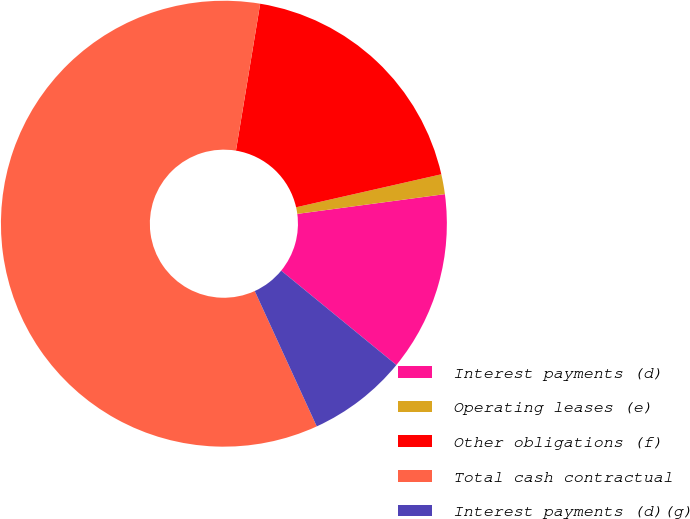Convert chart. <chart><loc_0><loc_0><loc_500><loc_500><pie_chart><fcel>Interest payments (d)<fcel>Operating leases (e)<fcel>Other obligations (f)<fcel>Total cash contractual<fcel>Interest payments (d)(g)<nl><fcel>13.04%<fcel>1.44%<fcel>18.84%<fcel>59.44%<fcel>7.24%<nl></chart> 